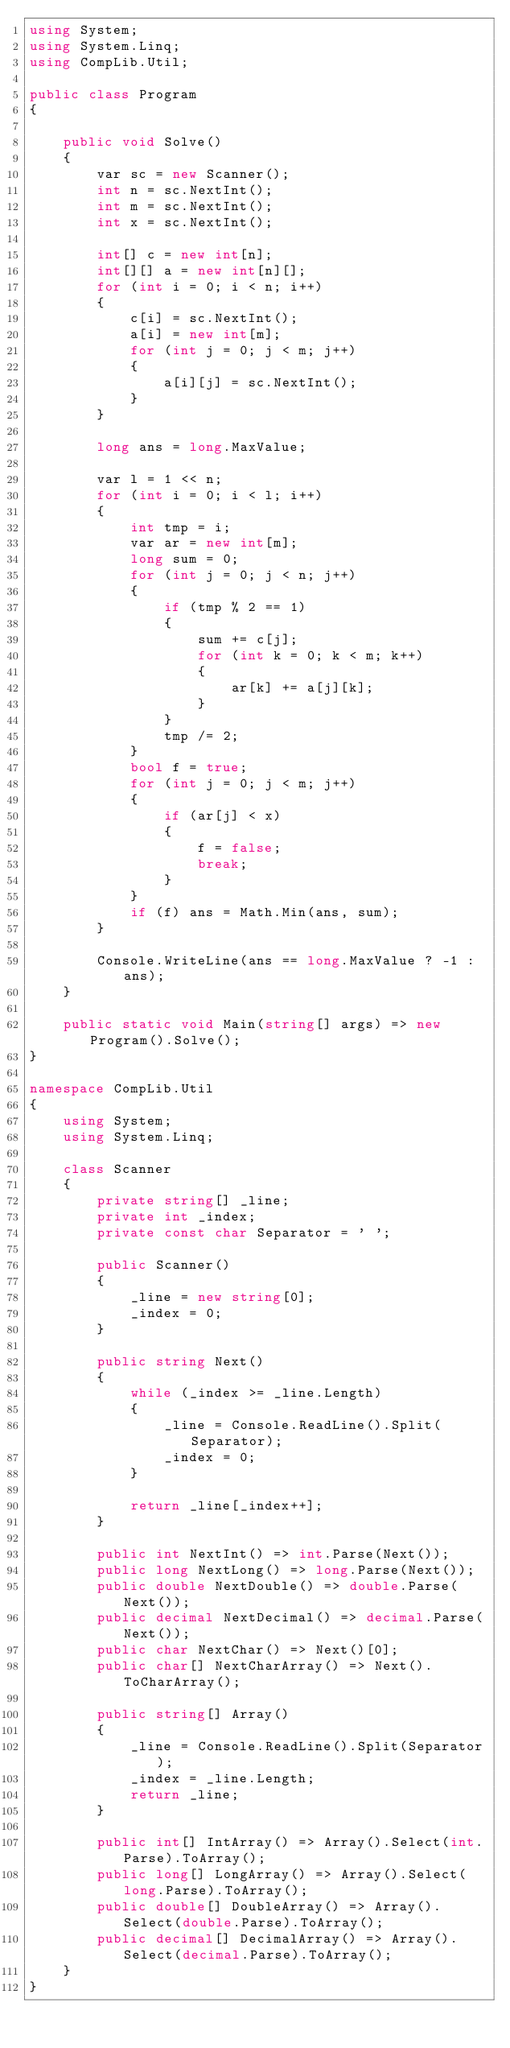Convert code to text. <code><loc_0><loc_0><loc_500><loc_500><_C#_>using System;
using System.Linq;
using CompLib.Util;

public class Program
{

    public void Solve()
    {
        var sc = new Scanner();
        int n = sc.NextInt();
        int m = sc.NextInt();
        int x = sc.NextInt();

        int[] c = new int[n];
        int[][] a = new int[n][];
        for (int i = 0; i < n; i++)
        {
            c[i] = sc.NextInt();
            a[i] = new int[m];
            for (int j = 0; j < m; j++)
            {
                a[i][j] = sc.NextInt();
            }
        }

        long ans = long.MaxValue;

        var l = 1 << n;
        for (int i = 0; i < l; i++)
        {
            int tmp = i;
            var ar = new int[m];
            long sum = 0;
            for (int j = 0; j < n; j++)
            {
                if (tmp % 2 == 1)
                {
                    sum += c[j];
                    for (int k = 0; k < m; k++)
                    {
                        ar[k] += a[j][k];
                    }
                }
                tmp /= 2;
            }
            bool f = true;
            for (int j = 0; j < m; j++)
            {
                if (ar[j] < x)
                {
                    f = false;
                    break;
                }
            }
            if (f) ans = Math.Min(ans, sum);
        }

        Console.WriteLine(ans == long.MaxValue ? -1 : ans);
    }

    public static void Main(string[] args) => new Program().Solve();
}

namespace CompLib.Util
{
    using System;
    using System.Linq;

    class Scanner
    {
        private string[] _line;
        private int _index;
        private const char Separator = ' ';

        public Scanner()
        {
            _line = new string[0];
            _index = 0;
        }

        public string Next()
        {
            while (_index >= _line.Length)
            {
                _line = Console.ReadLine().Split(Separator);
                _index = 0;
            }

            return _line[_index++];
        }

        public int NextInt() => int.Parse(Next());
        public long NextLong() => long.Parse(Next());
        public double NextDouble() => double.Parse(Next());
        public decimal NextDecimal() => decimal.Parse(Next());
        public char NextChar() => Next()[0];
        public char[] NextCharArray() => Next().ToCharArray();

        public string[] Array()
        {
            _line = Console.ReadLine().Split(Separator);
            _index = _line.Length;
            return _line;
        }

        public int[] IntArray() => Array().Select(int.Parse).ToArray();
        public long[] LongArray() => Array().Select(long.Parse).ToArray();
        public double[] DoubleArray() => Array().Select(double.Parse).ToArray();
        public decimal[] DecimalArray() => Array().Select(decimal.Parse).ToArray();
    }
}
</code> 